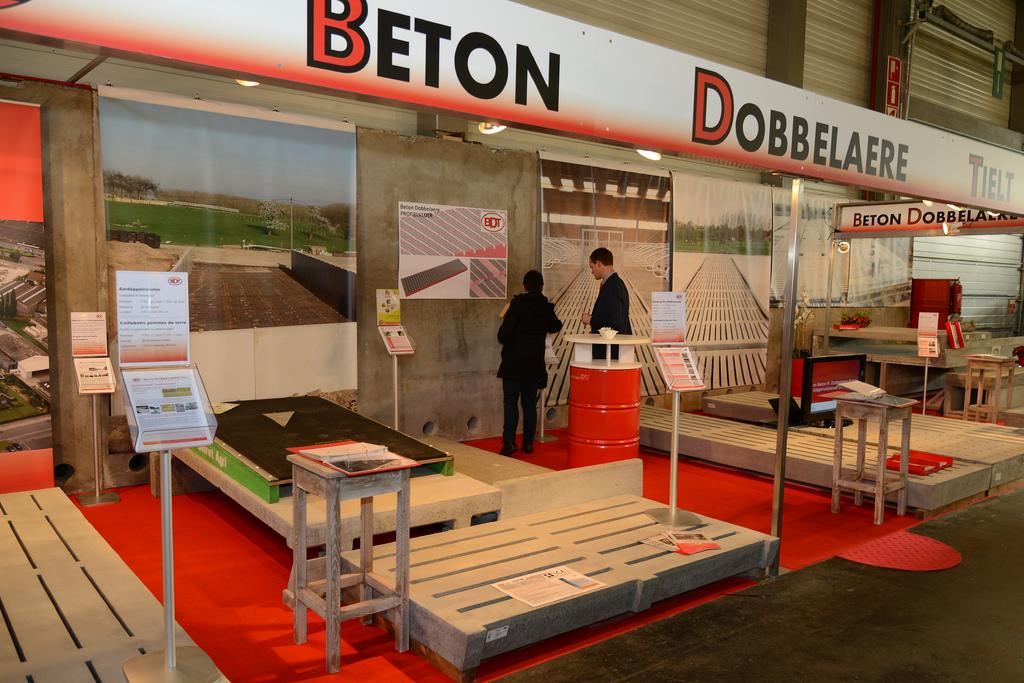How many people are in the image? There are two persons standing in the image. What type of furniture can be seen in the image? There are tables, chairs, and furniture on the floor in the image. What is present on the wall in the background? There are posters on the wall in the background. What type of lighting is visible in the image? There are lights visible in the image. What additional item can be seen in the image? There is a banner in the image. Can you tell me how many crooks are depicted in the image? There are no crooks depicted in the image; it features two people standing and various furniture and objects. What type of animal can be seen interacting with the banner in the image? There is no animal present in the image, let alone interacting with the banner. 